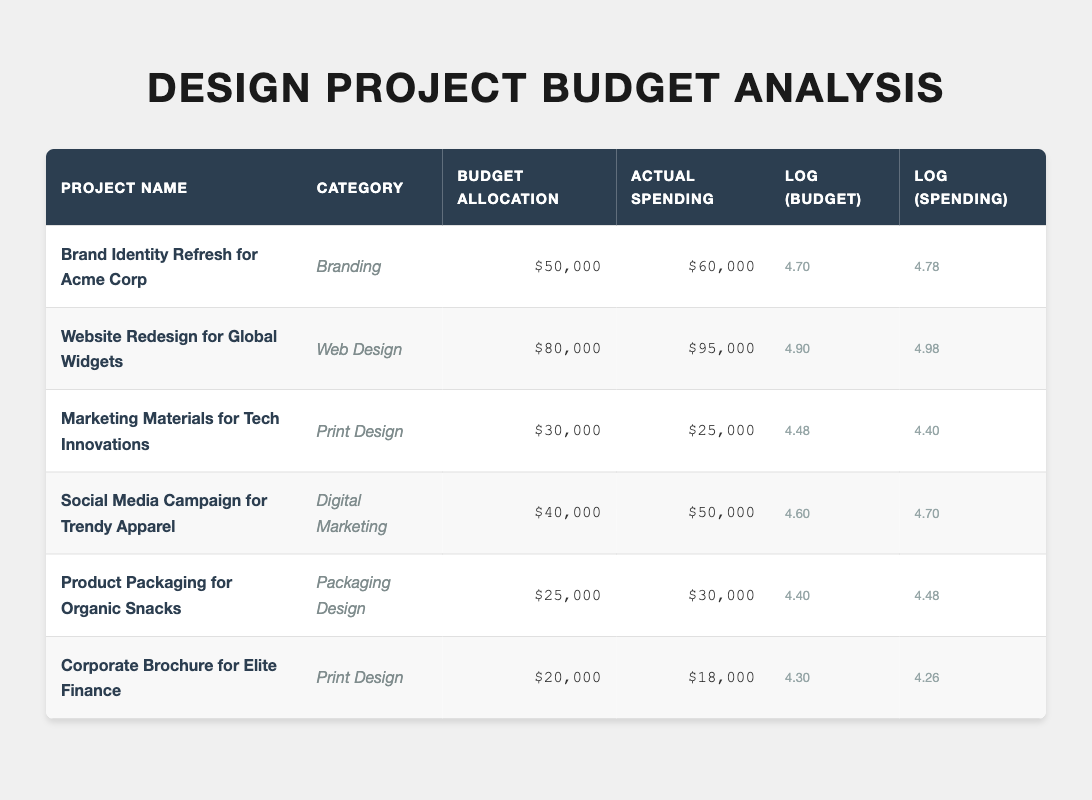What is the actual spending for the "Website Redesign for Global Widgets" project? The actual spending listed for the "Website Redesign for Global Widgets" project is $95,000. This value can be directly retrieved from the table under the "Actual Spending" column for the respective project.
Answer: $95,000 Which project spent more than its budget allocation? From the table, the projects that spent more than their budget allocation are: "Brand Identity Refresh for Acme Corp" ($60,000 vs $50,000), "Website Redesign for Global Widgets" ($95,000 vs $80,000), "Social Media Campaign for Trendy Apparel" ($50,000 vs $40,000), and "Product Packaging for Organic Snacks" ($30,000 vs $25,000). All these projects' actual spending exceeds the budget allocation.
Answer: Yes What is the total budget allocation for all projects in Print Design? There are two Print Design projects: "Marketing Materials for Tech Innovations" with a budget of $30,000, and "Corporate Brochure for Elite Finance" with a budget of $20,000. Adding these amounts together gives $30,000 + $20,000 = $50,000 for total budget allocation in Print Design.
Answer: $50,000 Which project had the largest difference between budget allocation and actual spending? The difference is calculated by subtracting budget allocation from actual spending. For "Brand Identity Refresh for Acme Corp," the difference is $60,000 - $50,000 = $10,000. For "Website Redesign for Global Widgets," it's $95,000 - $80,000 = $15,000. "Social Media Campaign for Trendy Apparel" has a difference of $50,000 - $40,000 = $10,000, while "Product Packaging for Organic Snacks" has $30,000 - $25,000 = $5,000. The largest difference is $15,000 from the "Website Redesign for Global Widgets."
Answer: Website Redesign for Global Widgets Is it true that the "Marketing Materials for Tech Innovations" project was completed under budget? The table shows that the actual spending for "Marketing Materials for Tech Innovations" was $25,000, while the budget allocation was $30,000. Since the spending is less than the budget, the project was indeed completed under budget.
Answer: Yes What is the average actual spending across all design projects? To find the average, the actual spending amounts ($60,000, $95,000, $25,000, $50,000, $30,000, and $18,000) need to be summed up: $60,000 + $95,000 + $25,000 + $50,000 + $30,000 + $18,000 = $278,000. There are 6 projects, so the average is $278,000 / 6 = $46,333.33, which rounds to $46,333 when considering whole dollars.
Answer: $46,333 